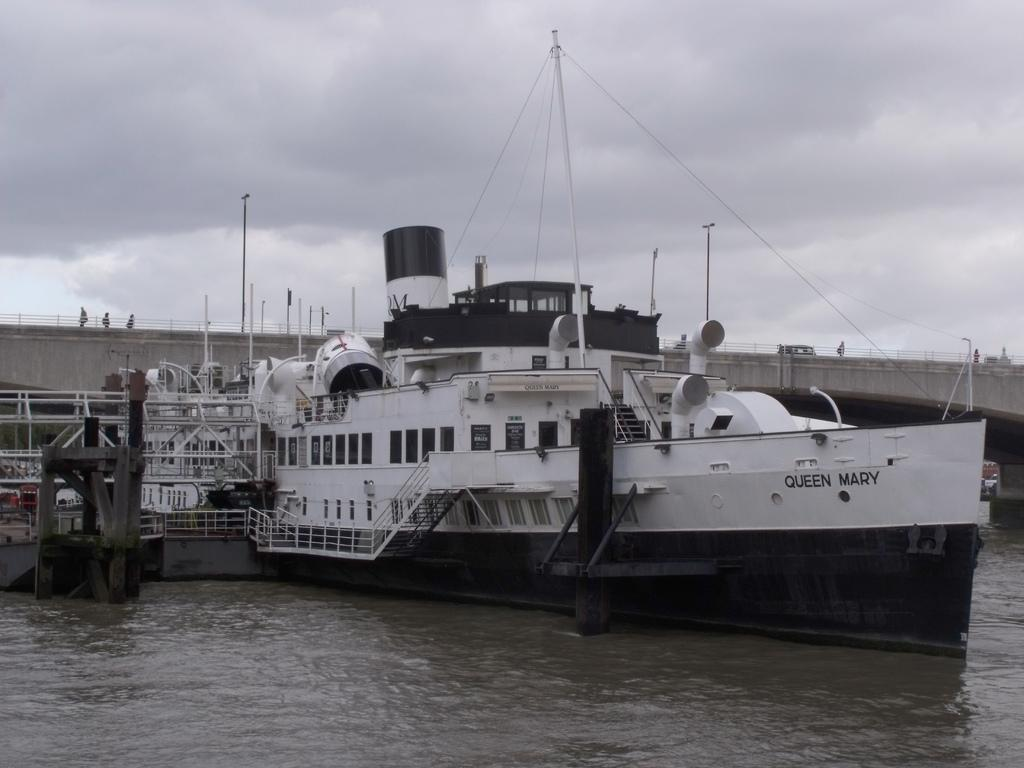What is the main subject in the middle of the lake in the image? There is a huge ship in the middle of the lake in the image. What can be seen behind the ship? There is a bridge behind the ship. What are the people on the bridge doing? The people walking on the bridge can be seen in the image. What is visible in the background of the image? The sky is visible in the image. What can be observed in the sky? Clouds are present in the sky. What type of book is being read by the police officer on the ship? There are no police officers or books present in the image. Is there a fight happening on the ship in the image? There is no fight depicted on the ship in the image. 